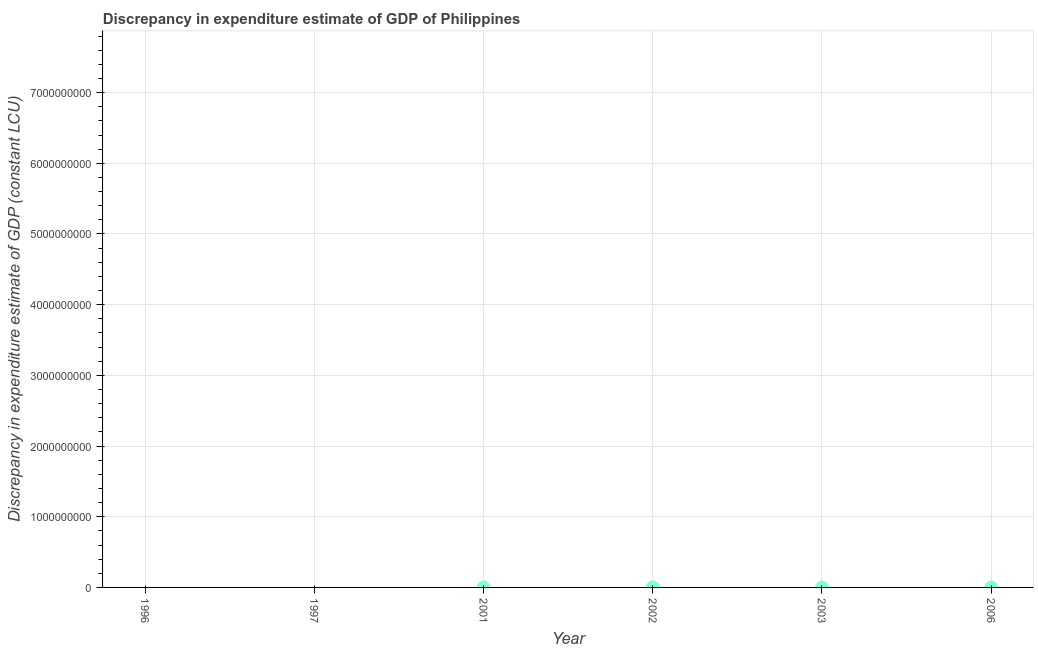Across all years, what is the maximum discrepancy in expenditure estimate of gdp?
Give a very brief answer. 100. Across all years, what is the minimum discrepancy in expenditure estimate of gdp?
Offer a very short reply. 0. In which year was the discrepancy in expenditure estimate of gdp maximum?
Offer a terse response. 2002. What is the sum of the discrepancy in expenditure estimate of gdp?
Ensure brevity in your answer.  300. What is the difference between the discrepancy in expenditure estimate of gdp in 2002 and 2006?
Your response must be concise. 0. What is the average discrepancy in expenditure estimate of gdp per year?
Offer a terse response. 50. What is the median discrepancy in expenditure estimate of gdp?
Offer a very short reply. 50. In how many years, is the discrepancy in expenditure estimate of gdp greater than 1200000000 LCU?
Your response must be concise. 0. What is the difference between the highest and the second highest discrepancy in expenditure estimate of gdp?
Your answer should be compact. 0. What is the difference between the highest and the lowest discrepancy in expenditure estimate of gdp?
Give a very brief answer. 100. What is the difference between two consecutive major ticks on the Y-axis?
Offer a terse response. 1.00e+09. What is the title of the graph?
Your answer should be very brief. Discrepancy in expenditure estimate of GDP of Philippines. What is the label or title of the Y-axis?
Offer a terse response. Discrepancy in expenditure estimate of GDP (constant LCU). What is the Discrepancy in expenditure estimate of GDP (constant LCU) in 1996?
Give a very brief answer. 0. What is the Discrepancy in expenditure estimate of GDP (constant LCU) in 1997?
Your answer should be compact. 0. What is the Discrepancy in expenditure estimate of GDP (constant LCU) in 2002?
Your answer should be very brief. 100. What is the difference between the Discrepancy in expenditure estimate of GDP (constant LCU) in 2002 and 2006?
Your answer should be compact. 0. What is the ratio of the Discrepancy in expenditure estimate of GDP (constant LCU) in 2002 to that in 2003?
Ensure brevity in your answer.  1. What is the ratio of the Discrepancy in expenditure estimate of GDP (constant LCU) in 2002 to that in 2006?
Offer a terse response. 1. 